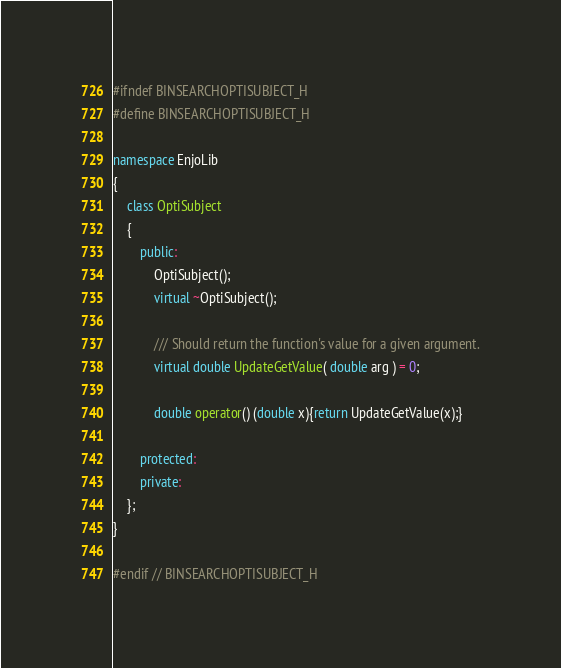<code> <loc_0><loc_0><loc_500><loc_500><_C++_>#ifndef BINSEARCHOPTISUBJECT_H
#define BINSEARCHOPTISUBJECT_H

namespace EnjoLib
{
    class OptiSubject
    {
        public:
            OptiSubject();
            virtual ~OptiSubject();

            /// Should return the function's value for a given argument.
            virtual double UpdateGetValue( double arg ) = 0;

            double operator() (double x){return UpdateGetValue(x);}

        protected:
        private:
    };
}

#endif // BINSEARCHOPTISUBJECT_H
</code> 